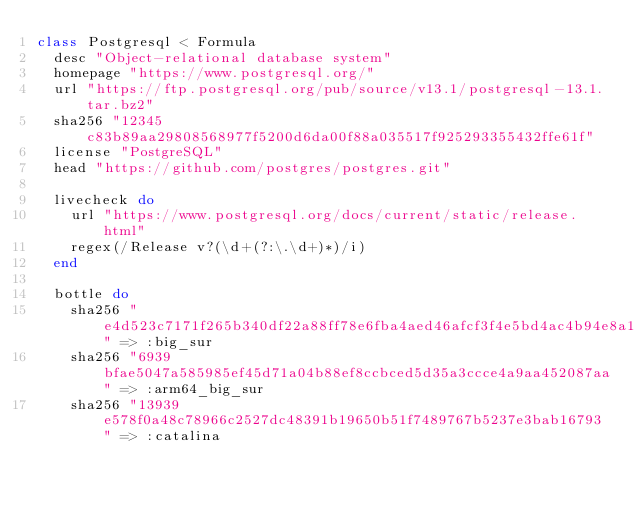<code> <loc_0><loc_0><loc_500><loc_500><_Ruby_>class Postgresql < Formula
  desc "Object-relational database system"
  homepage "https://www.postgresql.org/"
  url "https://ftp.postgresql.org/pub/source/v13.1/postgresql-13.1.tar.bz2"
  sha256 "12345c83b89aa29808568977f5200d6da00f88a035517f925293355432ffe61f"
  license "PostgreSQL"
  head "https://github.com/postgres/postgres.git"

  livecheck do
    url "https://www.postgresql.org/docs/current/static/release.html"
    regex(/Release v?(\d+(?:\.\d+)*)/i)
  end

  bottle do
    sha256 "e4d523c7171f265b340df22a88ff78e6fba4aed46afcf3f4e5bd4ac4b94e8a16" => :big_sur
    sha256 "6939bfae5047a585985ef45d71a04b88ef8ccbced5d35a3ccce4a9aa452087aa" => :arm64_big_sur
    sha256 "13939e578f0a48c78966c2527dc48391b19650b51f7489767b5237e3bab16793" => :catalina</code> 